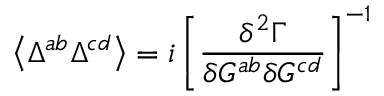Convert formula to latex. <formula><loc_0><loc_0><loc_500><loc_500>\left \langle \Delta ^ { a b } \Delta ^ { c d } \right \rangle = i \left [ \frac { \delta ^ { 2 } \Gamma } { \delta G ^ { a b } \delta G ^ { c d } } \right ] ^ { - 1 }</formula> 